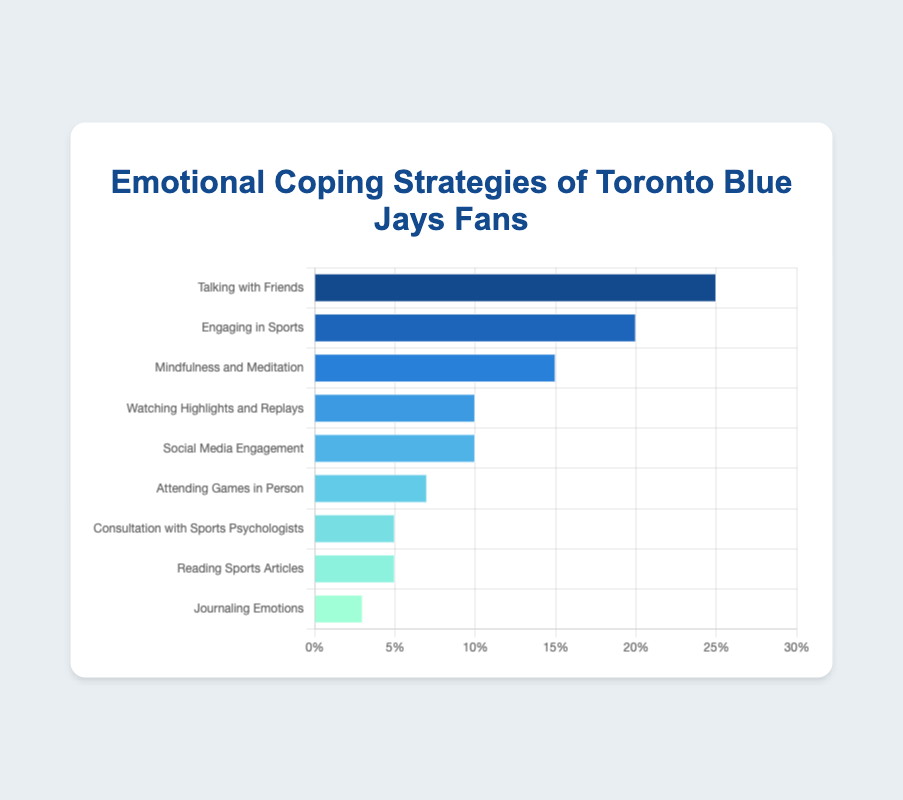What is the most common emotional coping strategy among Toronto Blue Jays fans? The bar representing "Talking with Friends" is the longest, covering 25% of the chart, which signifies it is the most common strategy.
Answer: Talking with Friends Which coping strategy is used least frequently by fans? The shortest bar in the chart corresponds to "Journaling Emotions", which accounts for just 3% of the strategies used.
Answer: Journaling Emotions How much greater is the percentage of "Engaging in Sports" compared to "Consultation with Sports Psychologists"? "Engaging in Sports" is at 20%, and "Consultation with Sports Psychologists" is at 5%, so the difference is 20% - 5% = 15%.
Answer: 15% If you sum the percentages of "Watching Highlights and Replays" and "Social Media Engagement", what is the total? Both "Watching Highlights and Replays" and "Social Media Engagement" have percentages of 10% each. Their sum is 10% + 10% = 20%.
Answer: 20% What is the combined percentage of strategies that involve interacting with others, such as "Talking with Friends" and "Social Media Engagement"? The percentages for "Talking with Friends" and "Social Media Engagement" are 25% and 10%, respectively. The combined percentage is 25% + 10% = 35%.
Answer: 35% Which coping strategy falls right in the middle in terms of usage percentage? Listing the strategies by percentage (25%, 20%, 15%, 10%, 10%, 7%, 5%, 5%, 3%), "Watching Highlights and Replays" and "Social Media Engagement", both with 10%, are in the middle.
Answer: Watching Highlights and Replays, Social Media Engagement How does the percentage of "Journaling Emotions" compare to "Attending Games in Person"? "Journaling Emotions" is at 3%, whereas "Attending Games in Person" is at 7%. Thus, "Attending Games in Person" is greater by 7% - 3% = 4%.
Answer: Attending Games in Person is greater by 4% What is the median percentage value of the coping strategies? Arranging the percentages in ascending order: 3%, 5%, 5%, 7%, 10%, 10%, 15%, 20%, 25%. The median is 10% (the middle value).
Answer: 10% By how much does "Mindfulness and Meditation" exceed "Reading Sports Articles" in terms of percentage points? "Mindfulness and Meditation" stands at 15%, while "Reading Sports Articles" is at 5%. Therefore, it exceeds by 15% - 5% = 10%.
Answer: 10% Which two strategies together make up exactly one-third of the total coping strategies, based on their percentages? "Talking with Friends" is 25% and "Engaging in Sports" is 20%. Together they exceed one-third. The next pair, "Talking with Friends" (25%) and "Mindfulness and Meditation" (15%), together is 40%. This trend continues, and we find "Engaging in Sports" (20%) and "Mindfulness and Meditation" (15%) total 35%, which exceeds one-third.
Answer: No pair exactly one-third 